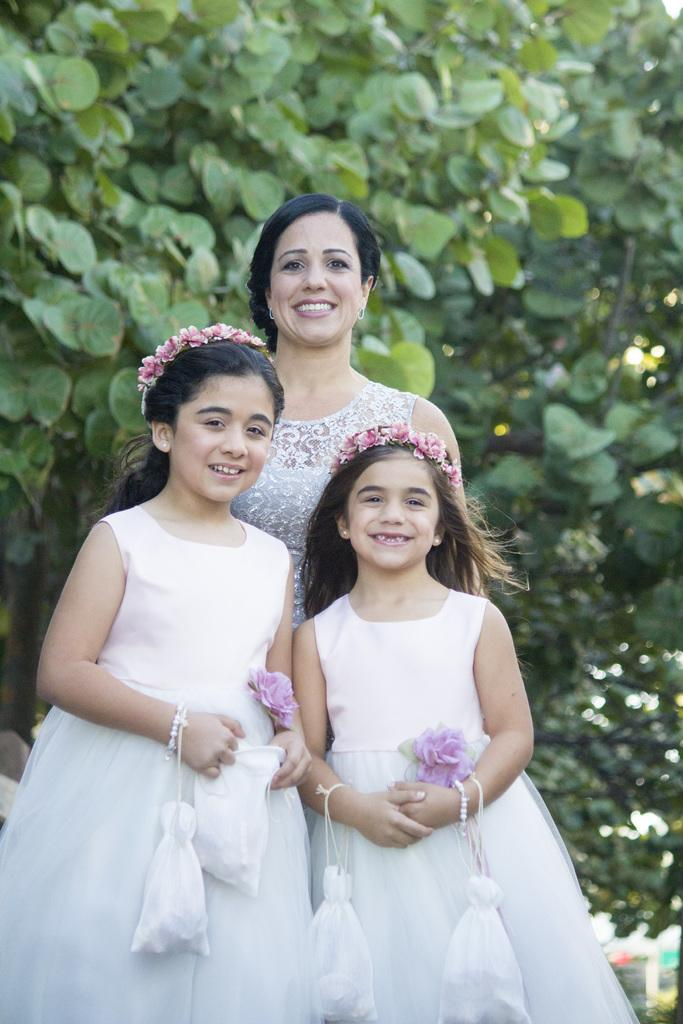What is happening in the image involving a group of people? There is a group of people in the image, and they are standing. How are the people in the image feeling or expressing themselves? The people in the image are smiling. What can be seen in the background of the image? There is a tree visible in the background of the image. What is the condition of the cattle in the image? There are no cattle present in the image. 